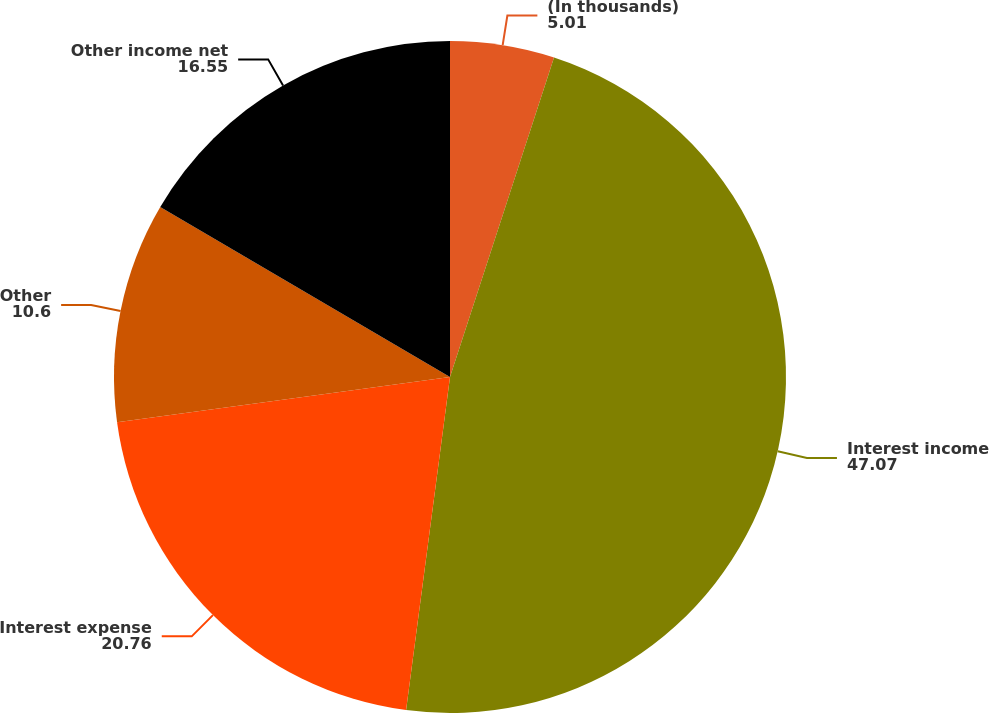<chart> <loc_0><loc_0><loc_500><loc_500><pie_chart><fcel>(In thousands)<fcel>Interest income<fcel>Interest expense<fcel>Other<fcel>Other income net<nl><fcel>5.01%<fcel>47.07%<fcel>20.76%<fcel>10.6%<fcel>16.55%<nl></chart> 